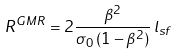<formula> <loc_0><loc_0><loc_500><loc_500>R ^ { G M R } = 2 \frac { \beta ^ { 2 } } { \sigma _ { 0 } \, ( 1 - \beta ^ { 2 } ) } \, l _ { s f }</formula> 